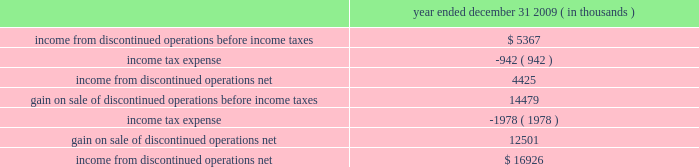$ 25.7 million in cash , including $ 4.2 million in taxes and 1373609 of hep 2019s common units having a fair value of $ 53.5 million .
Roadrunner / beeson pipelines transaction also on december 1 , 2009 , hep acquired our two newly constructed pipelines for $ 46.5 million , consisting of a 65- mile , 16-inch crude oil pipeline ( the 201croadrunner pipeline 201d ) that connects our navajo refinery lovington facility to a terminus of centurion pipeline l.p . 2019s pipeline extending between west texas and cushing , oklahoma and a 37- mile , 8-inch crude oil pipeline that connects hep 2019s new mexico crude oil gathering system to our navajo refinery lovington facility ( the 201cbeeson pipeline 201d ) .
Tulsa west loading racks transaction on august 1 , 2009 , hep acquired from us , certain truck and rail loading/unloading facilities located at our tulsa west facility for $ 17.5 million .
The racks load refined products and lube oils produced at the tulsa west facility onto rail cars and/or tanker trucks .
Lovington-artesia pipeline transaction on june 1 , 2009 , hep acquired our newly constructed , 16-inch intermediate pipeline for $ 34.2 million that runs 65 miles from our navajo refinery 2019s crude oil distillation and vacuum facilities in lovington , new mexico to its petroleum refinery located in artesia , new mexico .
Slc pipeline joint venture interest on march 1 , 2009 , hep acquired a 25% ( 25 % ) joint venture interest in the slc pipeline , a new 95-mile intrastate pipeline system jointly owned with plains .
The slc pipeline commenced operations effective march 2009 and allows various refineries in the salt lake city area , including our woods cross refinery , to ship crude oil into the salt lake city area from the utah terminus of the frontier pipeline as well as crude oil flowing from wyoming and utah via plains 2019 rocky mountain pipeline .
Hep 2019s capitalized joint venture contribution was $ 25.5 million .
Rio grande pipeline sale on december 1 , 2009 , hep sold its 70% ( 70 % ) interest in rio grande pipeline company ( 201crio grande 201d ) to a subsidiary of enterprise products partners lp for $ 35 million .
Results of operations of rio grande are presented in discontinued operations .
In accounting for this sale , hep recorded a gain of $ 14.5 million and a receivable of $ 2.2 million representing its final distribution from rio grande .
The recorded net asset balance of rio grande at december 1 , 2009 , was $ 22.7 million , consisting of cash of $ 3.1 million , $ 29.9 million in properties and equipment , net and $ 10.3 million in equity , representing bp , plc 2019s 30% ( 30 % ) noncontrolling interest .
The table provides income statement information related to hep 2019s discontinued operations : year ended december 31 , 2009 ( in thousands ) .
Transportation agreements hep serves our refineries under long-term pipeline and terminal , tankage and throughput agreements expiring in 2019 through 2026 .
Under these agreements , we pay hep fees to transport , store and throughput volumes of refined product and crude oil on hep 2019s pipeline and terminal , tankage and loading rack facilities that result in minimum annual payments to hep .
Under these agreements , the agreed upon tariff rates are subject to annual tariff rate adjustments on july 1 at a rate based upon the percentage change in producer price index ( 201cppi 201d ) or federal energy .
What was the tax rate on the gain on sale of discontinued operations before income taxes? 
Computations: (1978 / 14479)
Answer: 0.13661. 